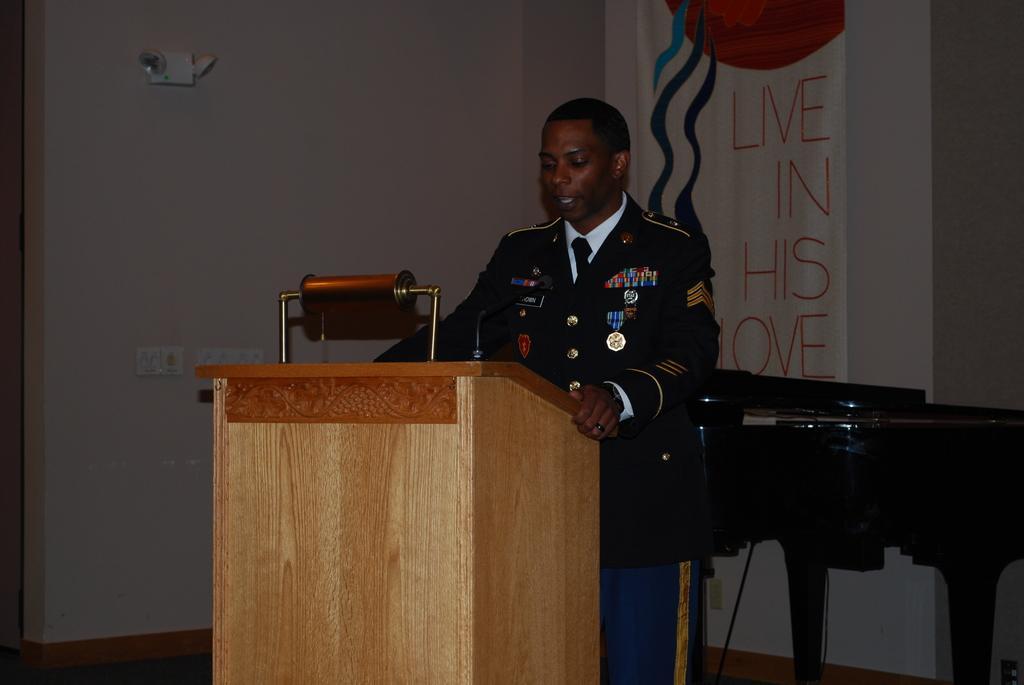Could you give a brief overview of what you see in this image? In this picture we can see man standing at podium and speaking and in background we can see table, banner, wall. 